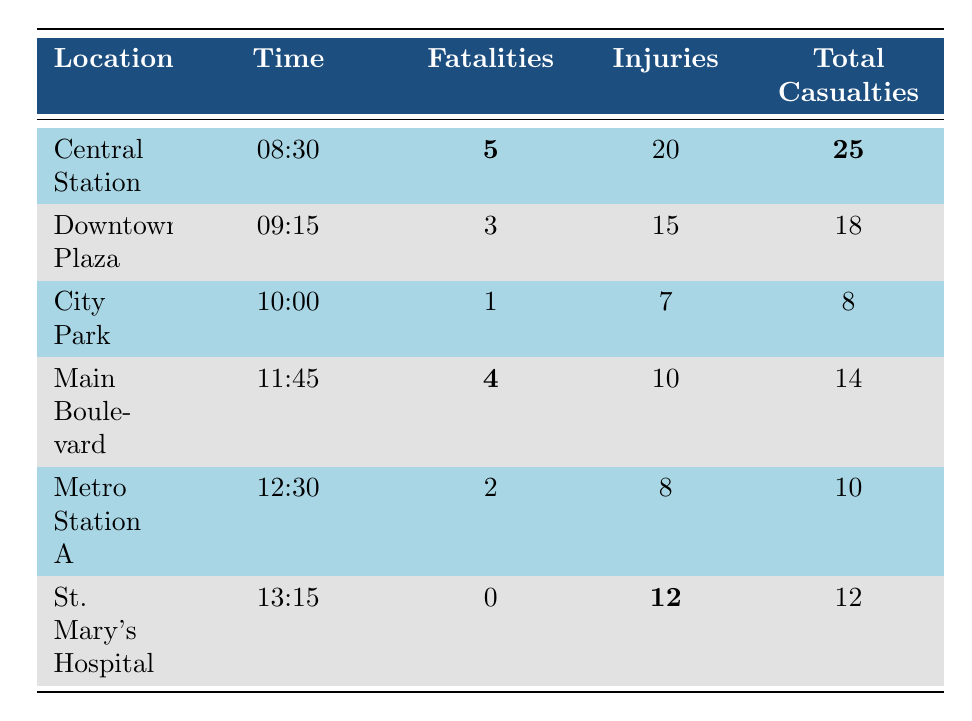What location had the highest number of fatalities? By examining the table, "Central Station" has the highest number of fatalities with **5**.
Answer: Central Station How many total casualties were reported in Downtown Plaza? The total casualties in Downtown Plaza are stated as **18** in the table.
Answer: 18 What is the total number of injuries reported across all locations? To get the total injuries, we add the injuries from each location: 20 + 15 + 7 + 10 + 8 + 12 = 72.
Answer: 72 Did St. Mary's Hospital report any fatalities? The table indicates that St. Mary's Hospital reported **0** fatalities.
Answer: No Which location had the lowest total casualties, and what was that number? The lowest total casualties are in "City Park" with **8** total casualties.
Answer: City Park; 8 What is the average number of fatalities reported across all locations? To calculate the average, we sum the fatalities: 5 + 3 + 1 + 4 + 2 + 0 = 15, then divide by the number of locations, which is 6: 15/6 = 2.5.
Answer: 2.5 Which location had the most injuries reported, and how many were there? St. Mary's Hospital has the most injuries reported with **12**.
Answer: St. Mary's Hospital; 12 What are the total casualties reported at Metro Station A? The number of total casualties reported at Metro Station A is **10** as per the table.
Answer: 10 Identify the time of the incident with the highest number of fatalities. The incident with the highest fatalities occurred at Central Station at **08:30**.
Answer: 08:30 What is the difference between the total casualties at Central Station and City Park? Central Station had **25** total casualties and City Park had **8**. The difference is 25 - 8 = 17.
Answer: 17 